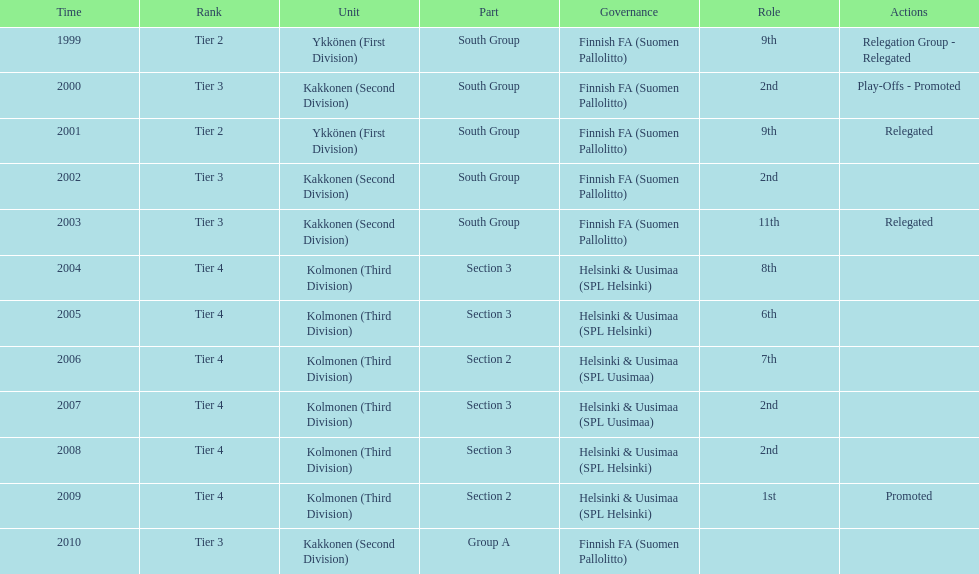When was the last year they placed 2nd? 2008. 